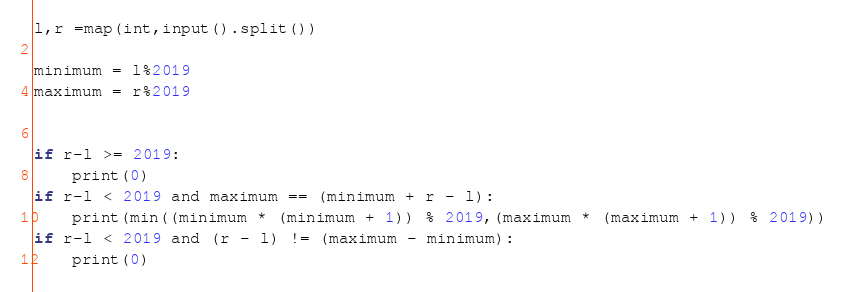<code> <loc_0><loc_0><loc_500><loc_500><_Python_>l,r =map(int,input().split())

minimum = l%2019
maximum = r%2019


if r-l >= 2019:
    print(0)
if r-l < 2019 and maximum == (minimum + r - l):
    print(min((minimum * (minimum + 1)) % 2019,(maximum * (maximum + 1)) % 2019))
if r-l < 2019 and (r - l) != (maximum - minimum):
    print(0)</code> 